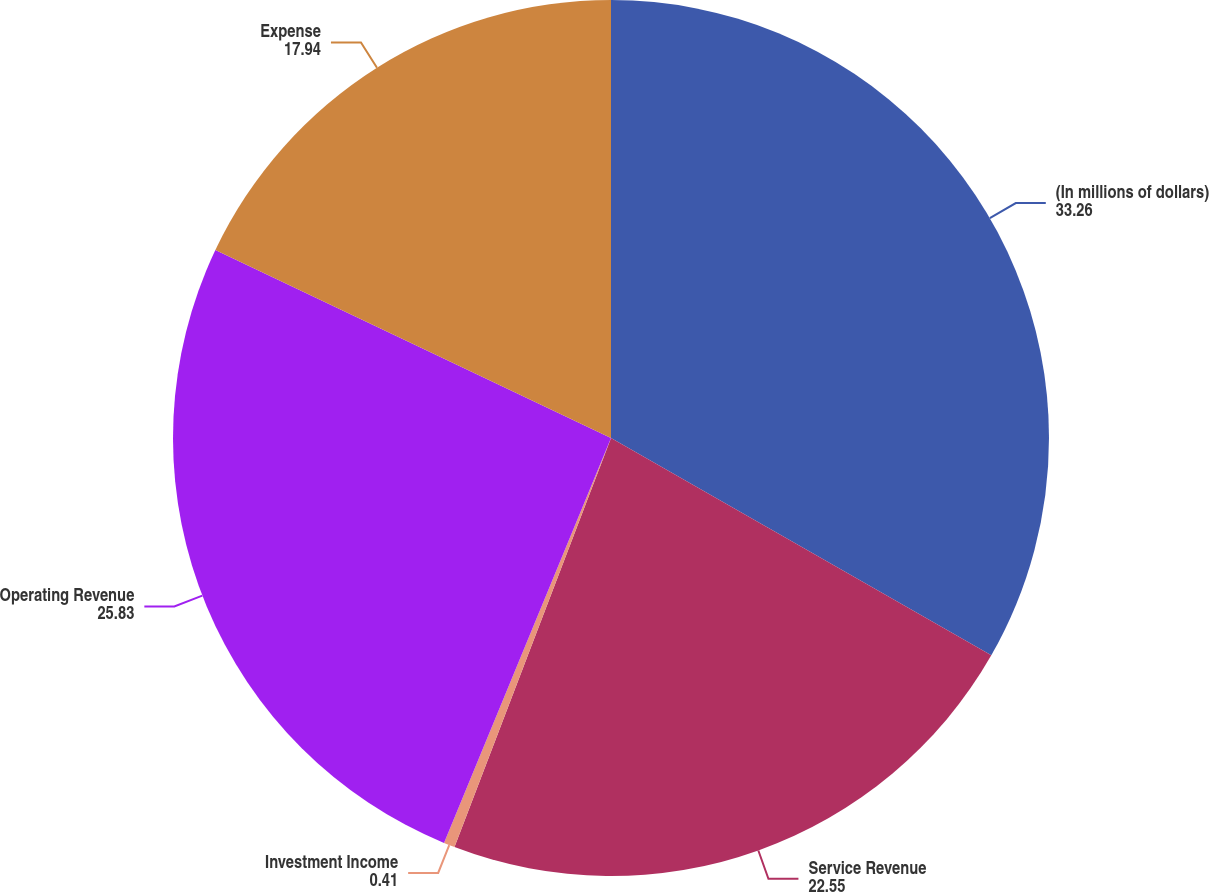Convert chart. <chart><loc_0><loc_0><loc_500><loc_500><pie_chart><fcel>(In millions of dollars)<fcel>Service Revenue<fcel>Investment Income<fcel>Operating Revenue<fcel>Expense<nl><fcel>33.26%<fcel>22.55%<fcel>0.41%<fcel>25.83%<fcel>17.94%<nl></chart> 